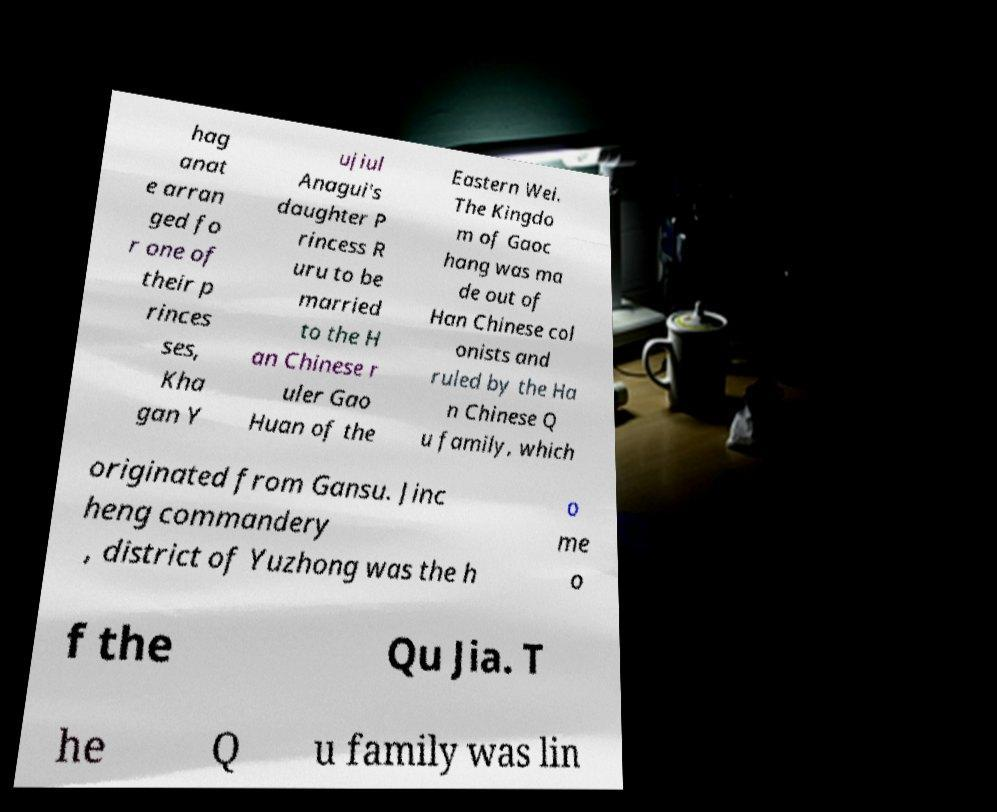Can you read and provide the text displayed in the image?This photo seems to have some interesting text. Can you extract and type it out for me? hag anat e arran ged fo r one of their p rinces ses, Kha gan Y ujiul Anagui's daughter P rincess R uru to be married to the H an Chinese r uler Gao Huan of the Eastern Wei. The Kingdo m of Gaoc hang was ma de out of Han Chinese col onists and ruled by the Ha n Chinese Q u family, which originated from Gansu. Jinc heng commandery , district of Yuzhong was the h o me o f the Qu Jia. T he Q u family was lin 